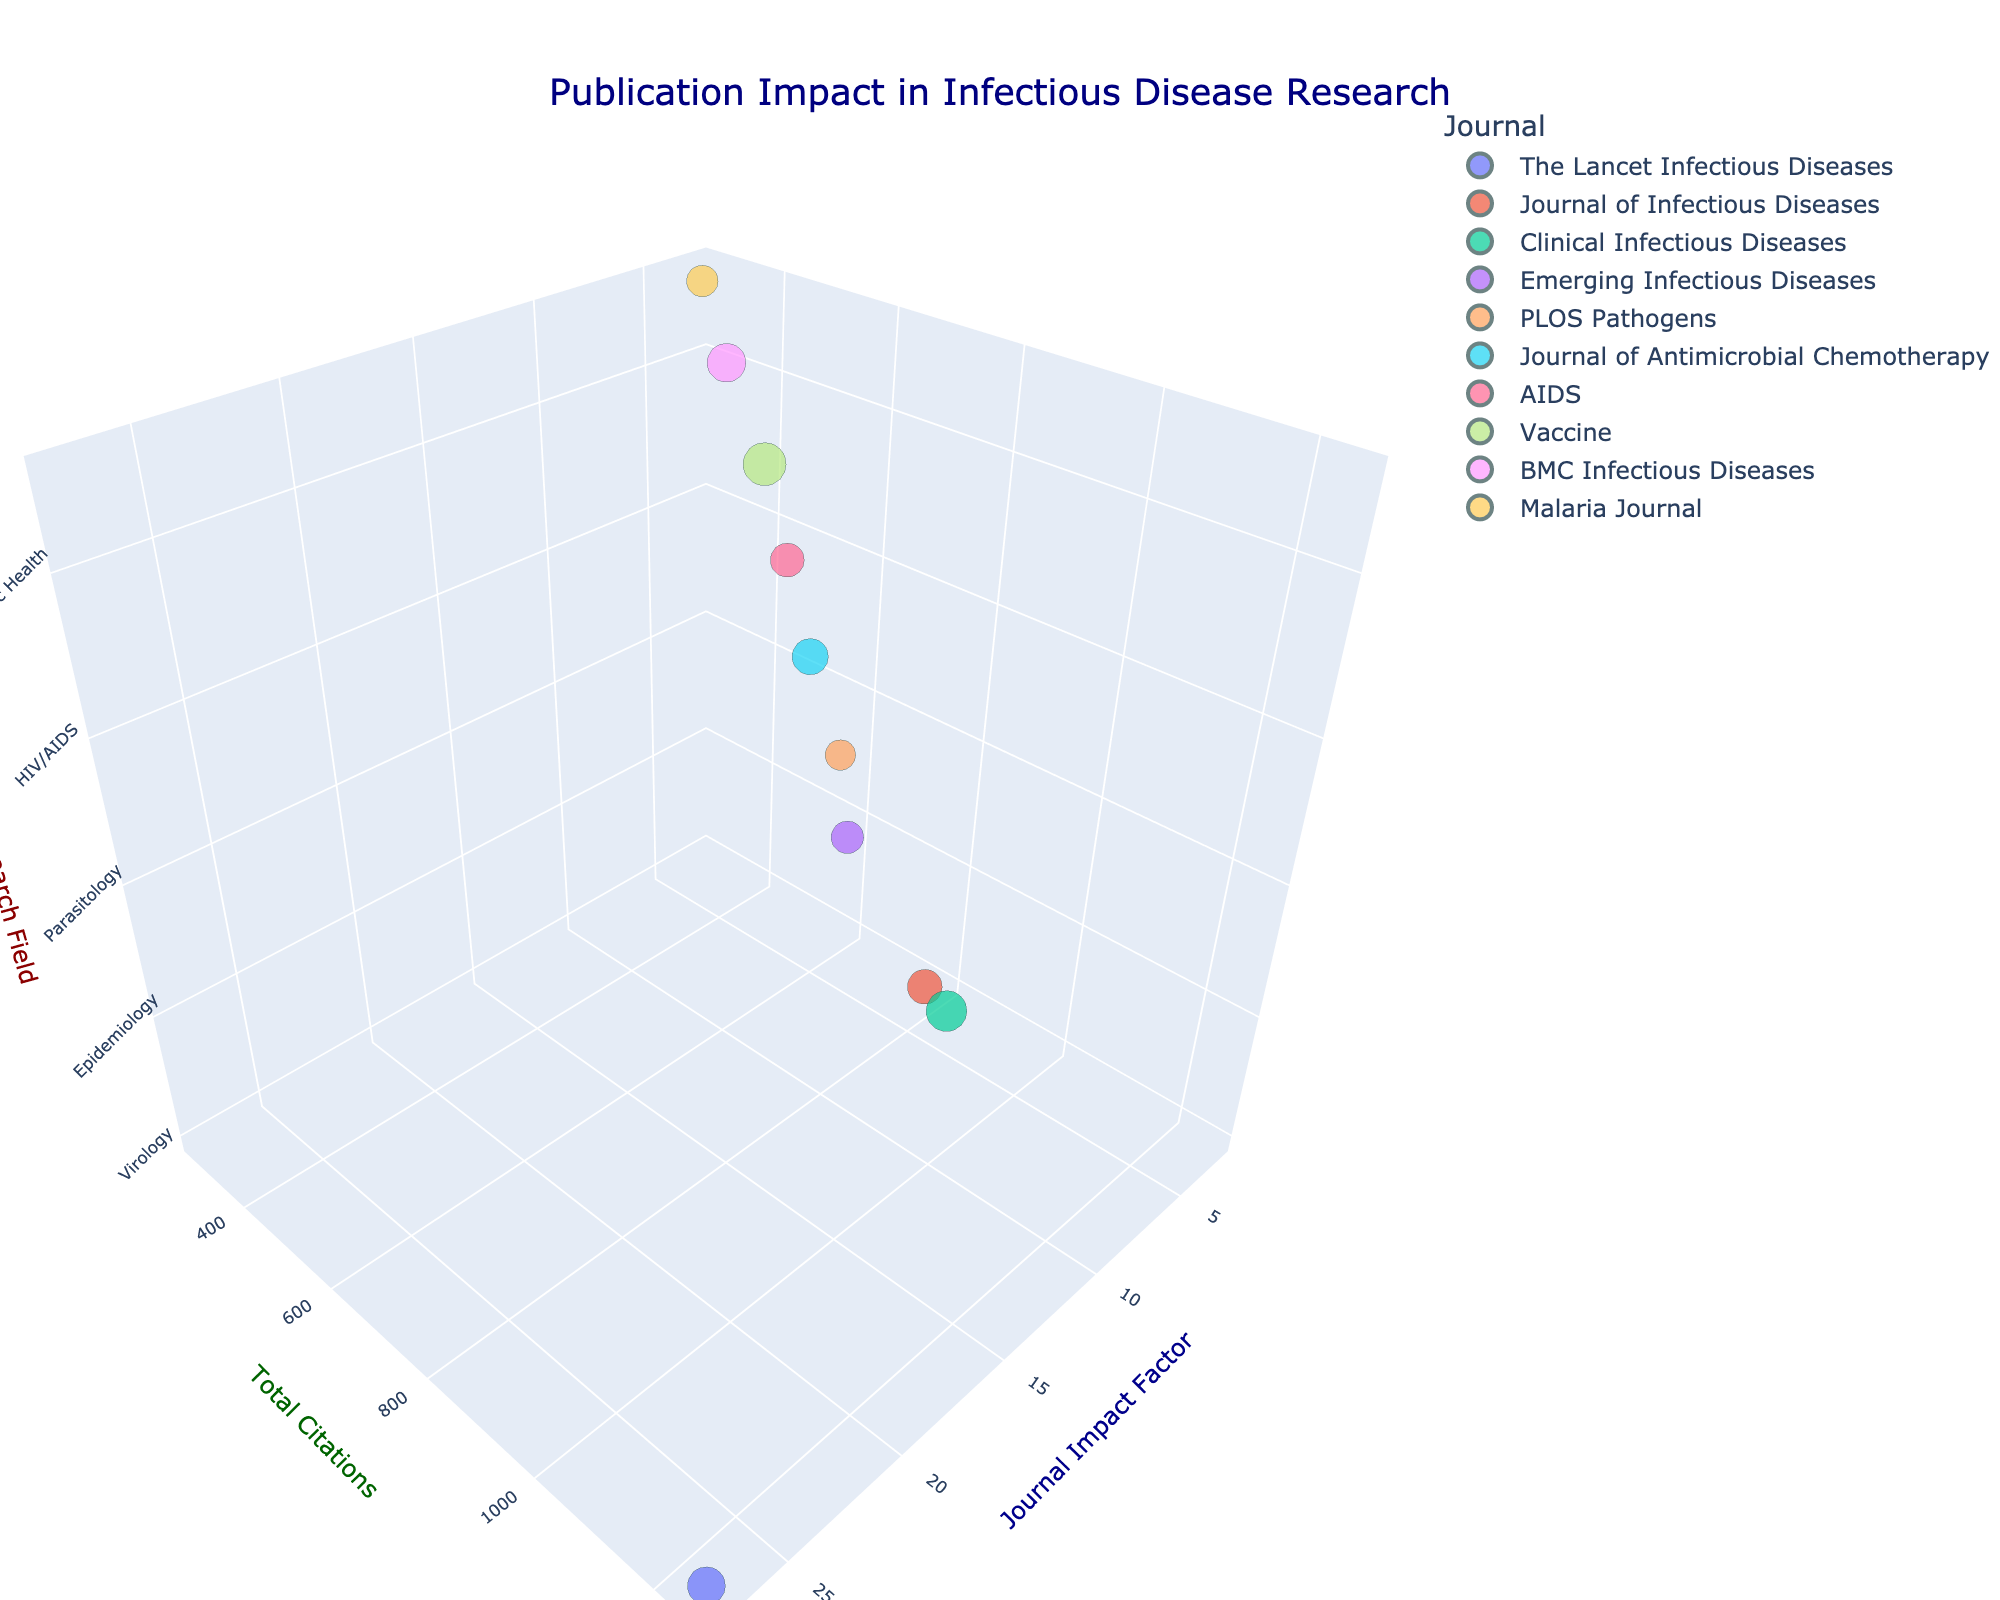What is the title of the chart? The title of the chart is prominently displayed at the top and is usually in a larger font size than other text elements.
Answer: Publication Impact in Infectious Disease Research Which journal has the highest impact factor? To identify this, look at the 'Impact Factor' axis and see which bubble is positioned the furthest along this axis. The bubble representing "The Lancet Infectious Diseases" is positioned the furthest along the Impact Factor axis.
Answer: The Lancet Infectious Diseases How many journals have an impact factor of more than 5? Observe the 'Impact Factor' axis and count the bubbles that are placed beyond 5 on this axis. There are six bubbles corresponding to "The Lancet Infectious Diseases", "Journal of Infectious Diseases", "Clinical Infectious Diseases", "Emerging Infectious Diseases", "PLOS Pathogens", and "Journal of Antimicrobial Chemotherapy".
Answer: Six Which research field has the highest total citation count for its top journal? Identify the bubbles with the highest Citation Count for each research field and compare them. "Virology" has the highest total citation count due to the "The Lancet Infectious Diseases" journal.
Answer: Virology Which journal has the largest bubble size and what is its publication count? Identify the bubble with the largest size by visually comparing the bubbles. The journal "Vaccine" has the largest bubble size, indicating it has the highest publication count, which is 58.
Answer: Vaccine, 58 What is the difference in citation count between "Clinical Infectious Diseases" and "Emerging Infectious Diseases"? Locate the corresponding bubbles, note their Citation Counts ("Clinical Infectious Diseases" has 980 and "Emerging Infectious Diseases" has 720), then calculate the difference: 980 - 720.
Answer: 260 Compare the relationship between impact factors and citation counts for "Journal of Infectious Diseases" and "PLOS Pathogens". Which has a higher citation count for a similar impact factor? Find the bubbles for both journals and check their Impact Factor and Citation Count. Both journals have similar impact factors (~6.2 and 5.9), but "Journal of Infectious Diseases" has a higher citation count (850 vs. 680).
Answer: Journal of Infectious Diseases What is the median impact factor of all journals in the figure? List all the impact factors: 27.5, 5.9, 9.1, 6.8, 6.2, 5.4, 4.5, 3.6, 2.7, 2.9. Order them: 2.7, 2.9, 3.6, 4.5, 5.4, 5.9, 6.2, 6.8, 9.1, 27.5. The median is the middle value in the ordered list, which is 5.65 (the average of 5.4 and 5.9).
Answer: 5.65 